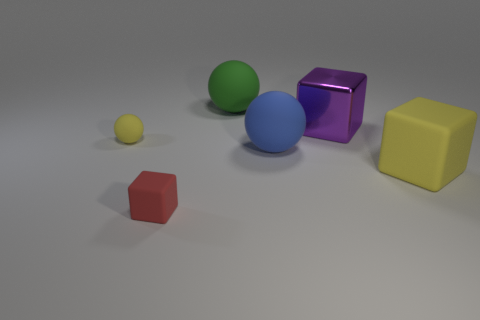Add 3 tiny objects. How many objects exist? 9 Subtract 1 green spheres. How many objects are left? 5 Subtract all red cubes. Subtract all large rubber blocks. How many objects are left? 4 Add 5 blue matte spheres. How many blue matte spheres are left? 6 Add 6 green balls. How many green balls exist? 7 